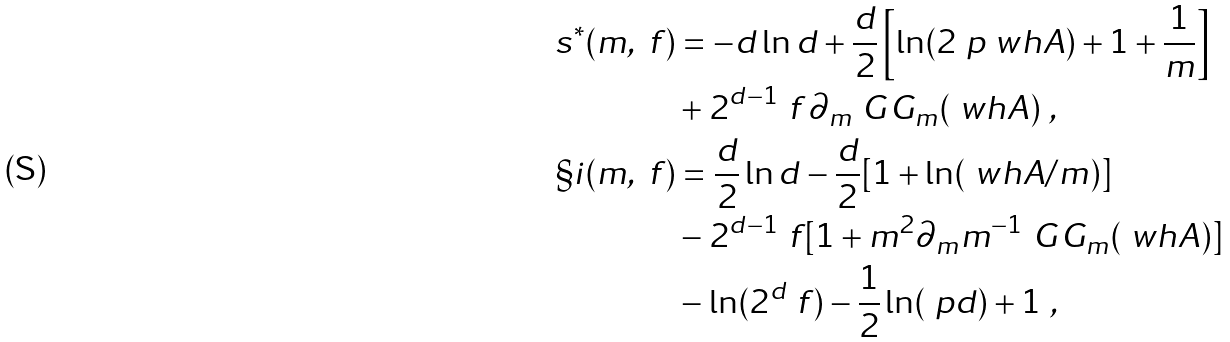Convert formula to latex. <formula><loc_0><loc_0><loc_500><loc_500>s ^ { * } ( m , \ f ) & = - d \ln d + \frac { d } 2 \left [ \ln ( 2 \ p \ w h A ) + 1 + \frac { 1 } { m } \right ] \\ & + 2 ^ { d - 1 } \ f \, \partial _ { m } \ G G _ { m } ( \ w h A ) \ , \\ \S i ( m , \ f ) & = \frac { d } 2 \ln d - \frac { d } 2 [ 1 + \ln ( \ w h A / m ) ] \\ & - 2 ^ { d - 1 } \ f [ 1 + m ^ { 2 } \partial _ { m } m ^ { - 1 } \ G G _ { m } ( \ w h A ) ] \\ & - \ln ( 2 ^ { d } \ f ) - \frac { 1 } { 2 } \ln ( \ p d ) + 1 \ ,</formula> 